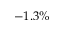Convert formula to latex. <formula><loc_0><loc_0><loc_500><loc_500>- 1 . 3 \%</formula> 